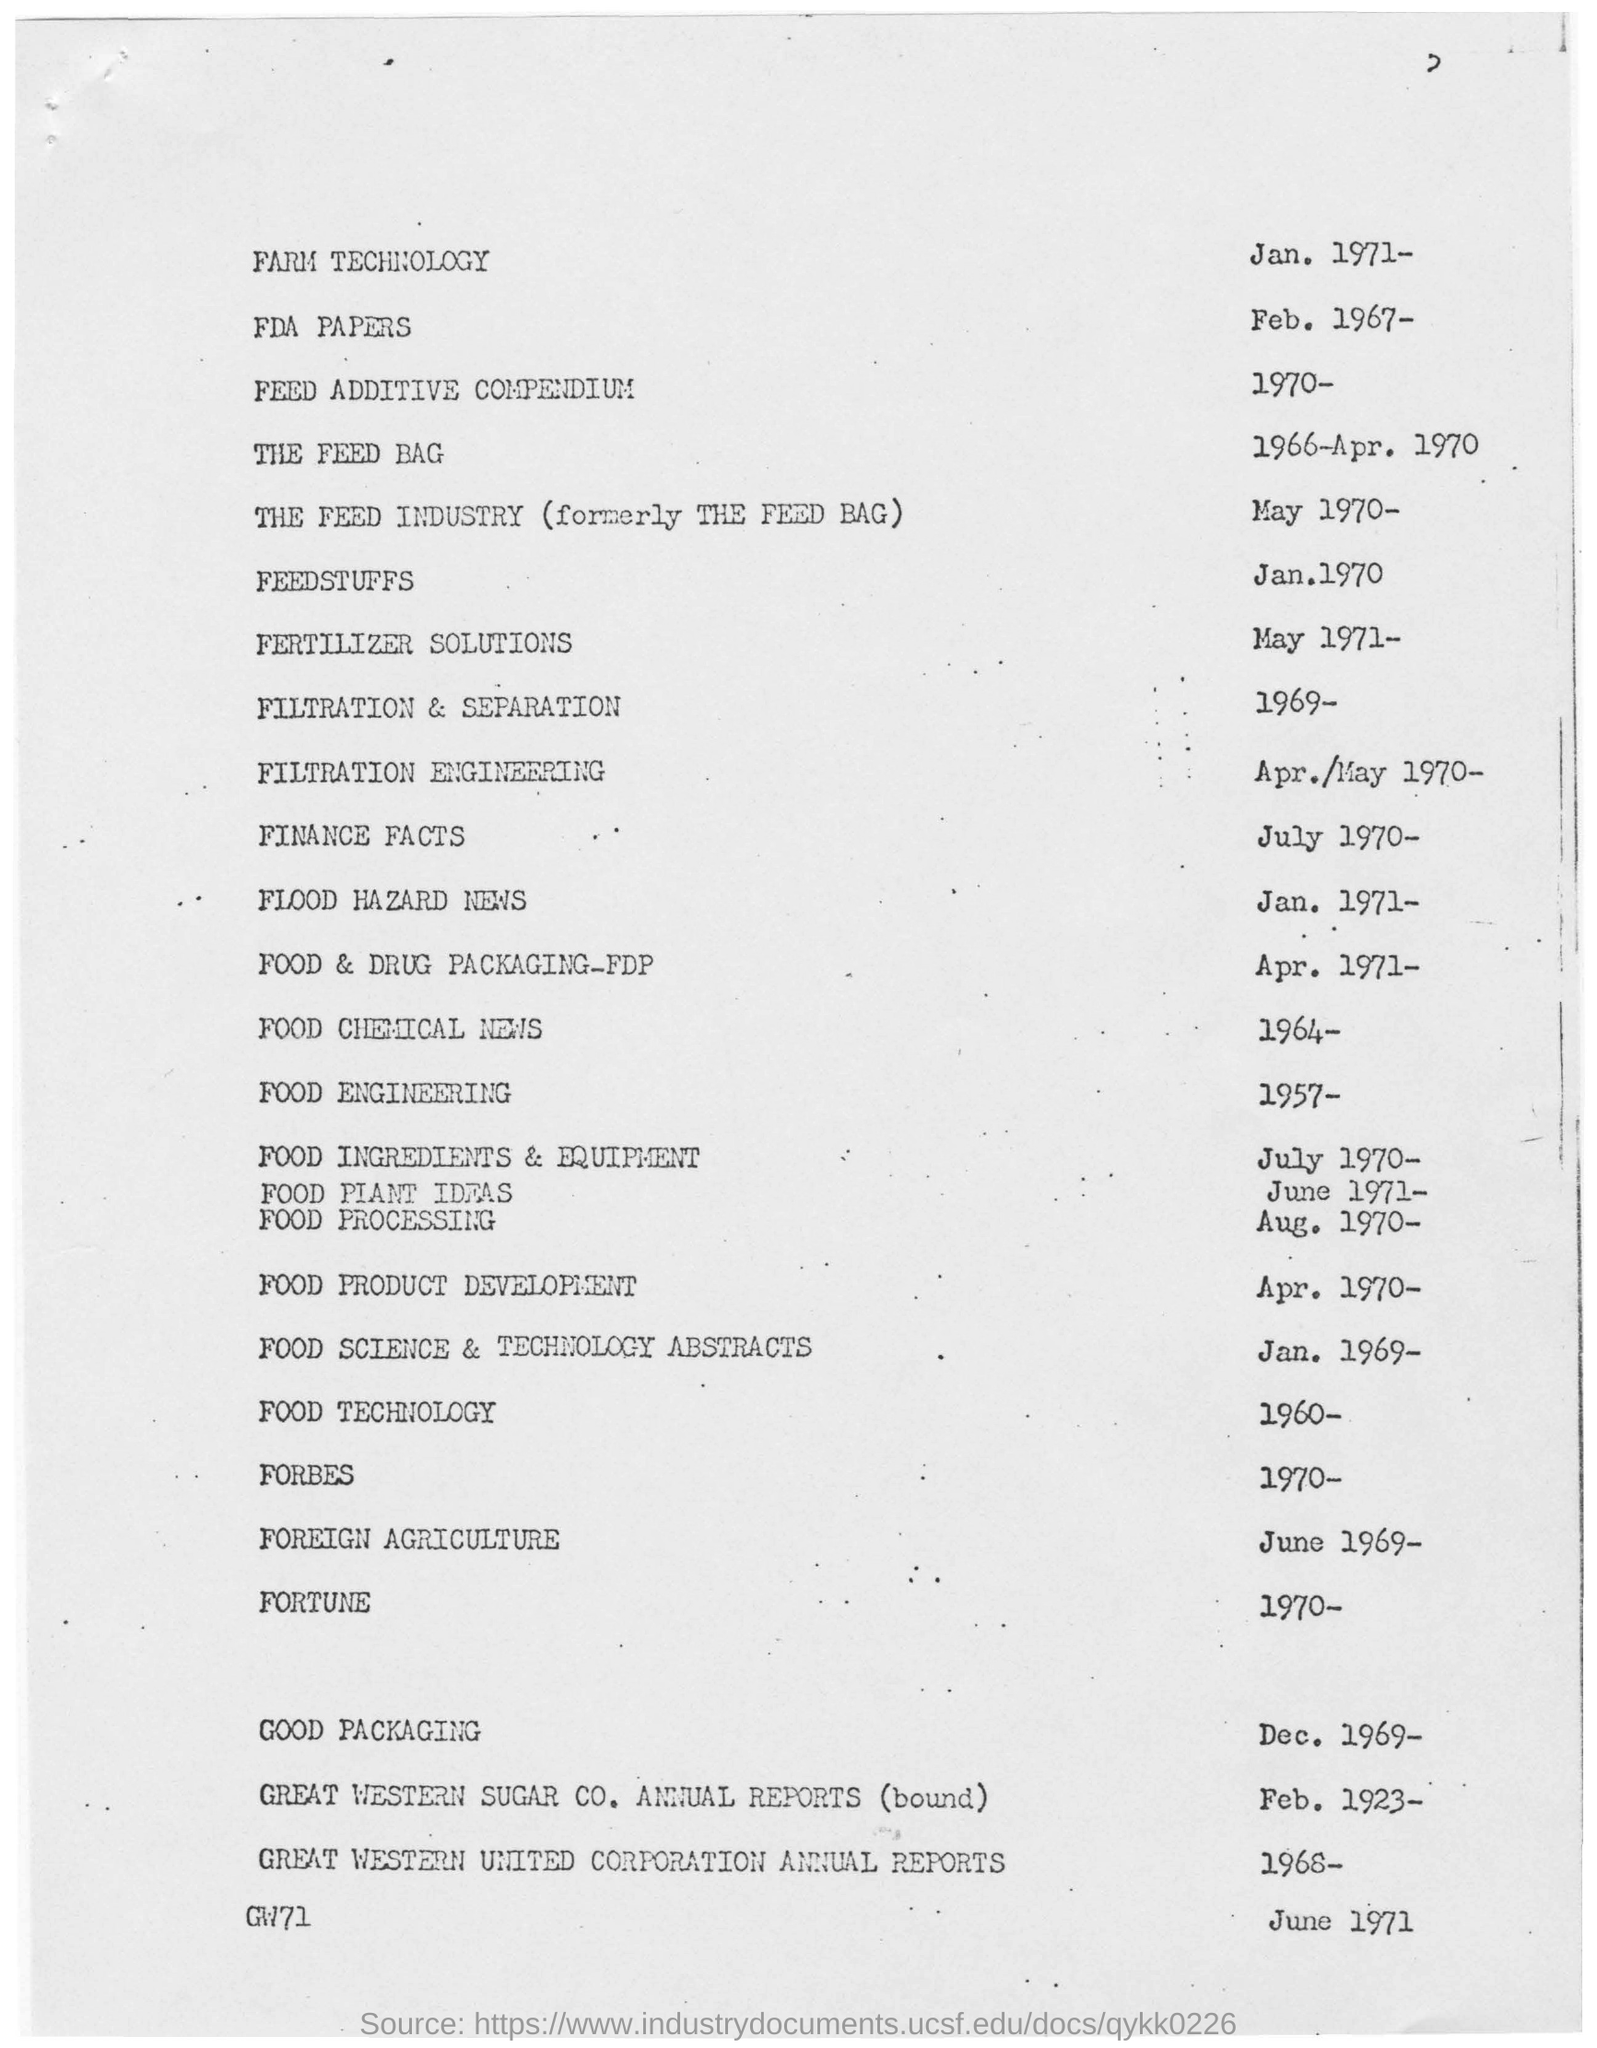Give some essential details in this illustration. The year mentioned for farm technology is 1971. 